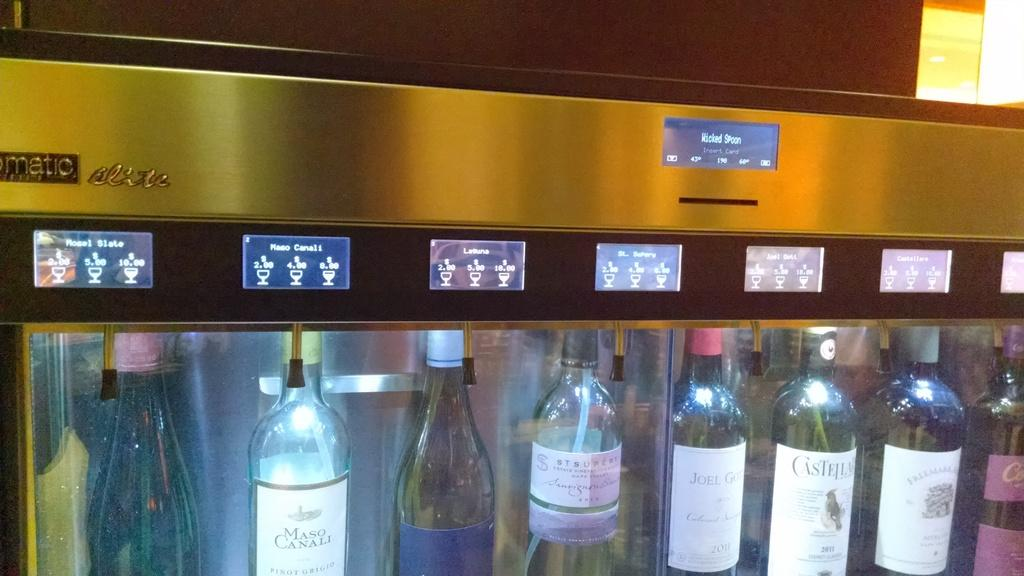What type of appliance is visible in the image? There is a fridge in the image. What feature does the fridge have? The fridge has a glass door. What items can be seen inside the fridge? Alcohol bottles are placed inside the fridge. What type of bead is used to decorate the judge's robe in the image? There is no judge or robe present in the image, so there is no bead to be described. 